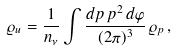Convert formula to latex. <formula><loc_0><loc_0><loc_500><loc_500>\varrho _ { u } = \frac { 1 } { n _ { \nu } } \int \frac { d p \, p ^ { 2 } \, d \varphi } { ( 2 \pi ) ^ { 3 } } \, \varrho _ { p } \, ,</formula> 